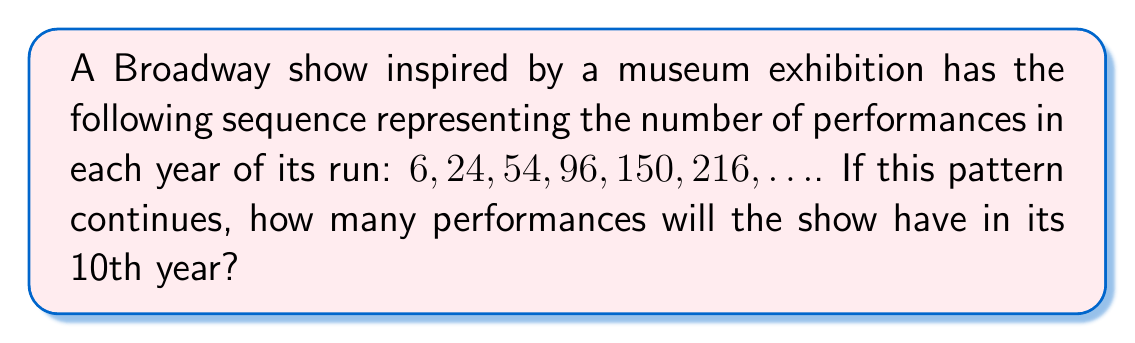Help me with this question. Let's approach this step-by-step:

1) First, let's examine the differences between consecutive terms:
   $24 - 6 = 18$
   $54 - 24 = 30$
   $96 - 54 = 42$
   $150 - 96 = 54$
   $216 - 150 = 66$

2) We can see that these differences are increasing by a constant amount:
   $30 - 18 = 12$
   $42 - 30 = 12$
   $54 - 42 = 12$
   $66 - 54 = 12$

3) This suggests that the sequence is a quadratic sequence, where the second differences are constant.

4) The general form of a quadratic sequence is:
   $a_n = an^2 + bn + c$, where $n$ is the term number.

5) To find $a$, we can use the fact that the second difference is constant and equal to $2a$:
   $12 = 2a$
   $a = 6$

6) Now we can use the first term to find $c$:
   $6 = a(1)^2 + b(1) + c$
   $6 = 6 + b + c$

7) And the second term to find $b$:
   $24 = a(2)^2 + b(2) + c$
   $24 = 24 + 2b + (6 - b - 6)$
   $24 = 24 + b - 6$
   $b = 6$

8) Therefore, our sequence is given by:
   $a_n = 6n^2 + 6n - 6$

9) For the 10th year, we substitute $n = 10$:
   $a_{10} = 6(10)^2 + 6(10) - 6$
   $= 600 + 60 - 6$
   $= 654$

Thus, in its 10th year, the show will have 654 performances.
Answer: 654 